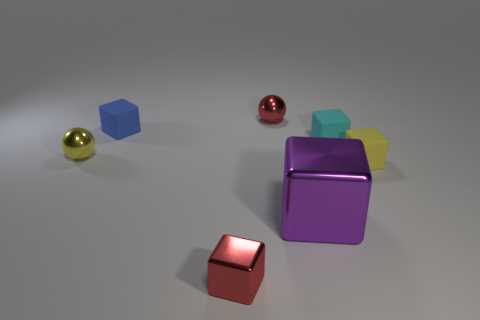What is the shape of the tiny red object that is in front of the tiny yellow block?
Offer a terse response. Cube. There is a shiny object that is the same color as the tiny metallic block; what size is it?
Your answer should be compact. Small. Is there a yellow matte cube that has the same size as the purple object?
Offer a terse response. No. Is the tiny red object in front of the tiny blue object made of the same material as the small blue thing?
Your answer should be very brief. No. Is the number of small blue matte objects that are on the right side of the small red metal ball the same as the number of purple metal objects behind the small cyan object?
Your answer should be compact. Yes. What shape is the small thing that is right of the tiny shiny block and left of the cyan object?
Make the answer very short. Sphere. There is a small blue object; what number of tiny cyan matte cubes are behind it?
Provide a short and direct response. 0. What number of other objects are the same shape as the large shiny thing?
Provide a succinct answer. 4. Are there fewer large green metal cubes than blue things?
Keep it short and to the point. Yes. How big is the metal thing that is on the right side of the tiny red cube and in front of the blue rubber cube?
Provide a short and direct response. Large. 